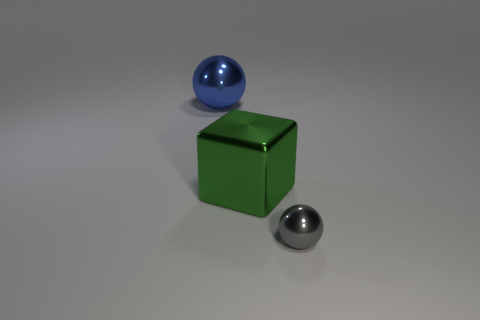What shape is the big green thing?
Your answer should be very brief. Cube. Do the green block and the blue sphere have the same size?
Provide a short and direct response. Yes. Are there any other things that are the same shape as the tiny metal thing?
Give a very brief answer. Yes. Are the tiny gray sphere and the ball behind the tiny thing made of the same material?
Offer a very short reply. Yes. There is a shiny sphere behind the tiny shiny ball; is its color the same as the tiny metallic ball?
Provide a short and direct response. No. What number of shiny spheres are both in front of the large blue thing and behind the big green metallic thing?
Your answer should be very brief. 0. What number of other objects are the same material as the green block?
Give a very brief answer. 2. Are the large thing to the right of the blue metallic ball and the blue ball made of the same material?
Give a very brief answer. Yes. How big is the ball that is on the left side of the metallic ball that is in front of the metallic ball that is behind the cube?
Make the answer very short. Large. What is the shape of the blue shiny thing that is the same size as the green metal cube?
Your answer should be compact. Sphere. 